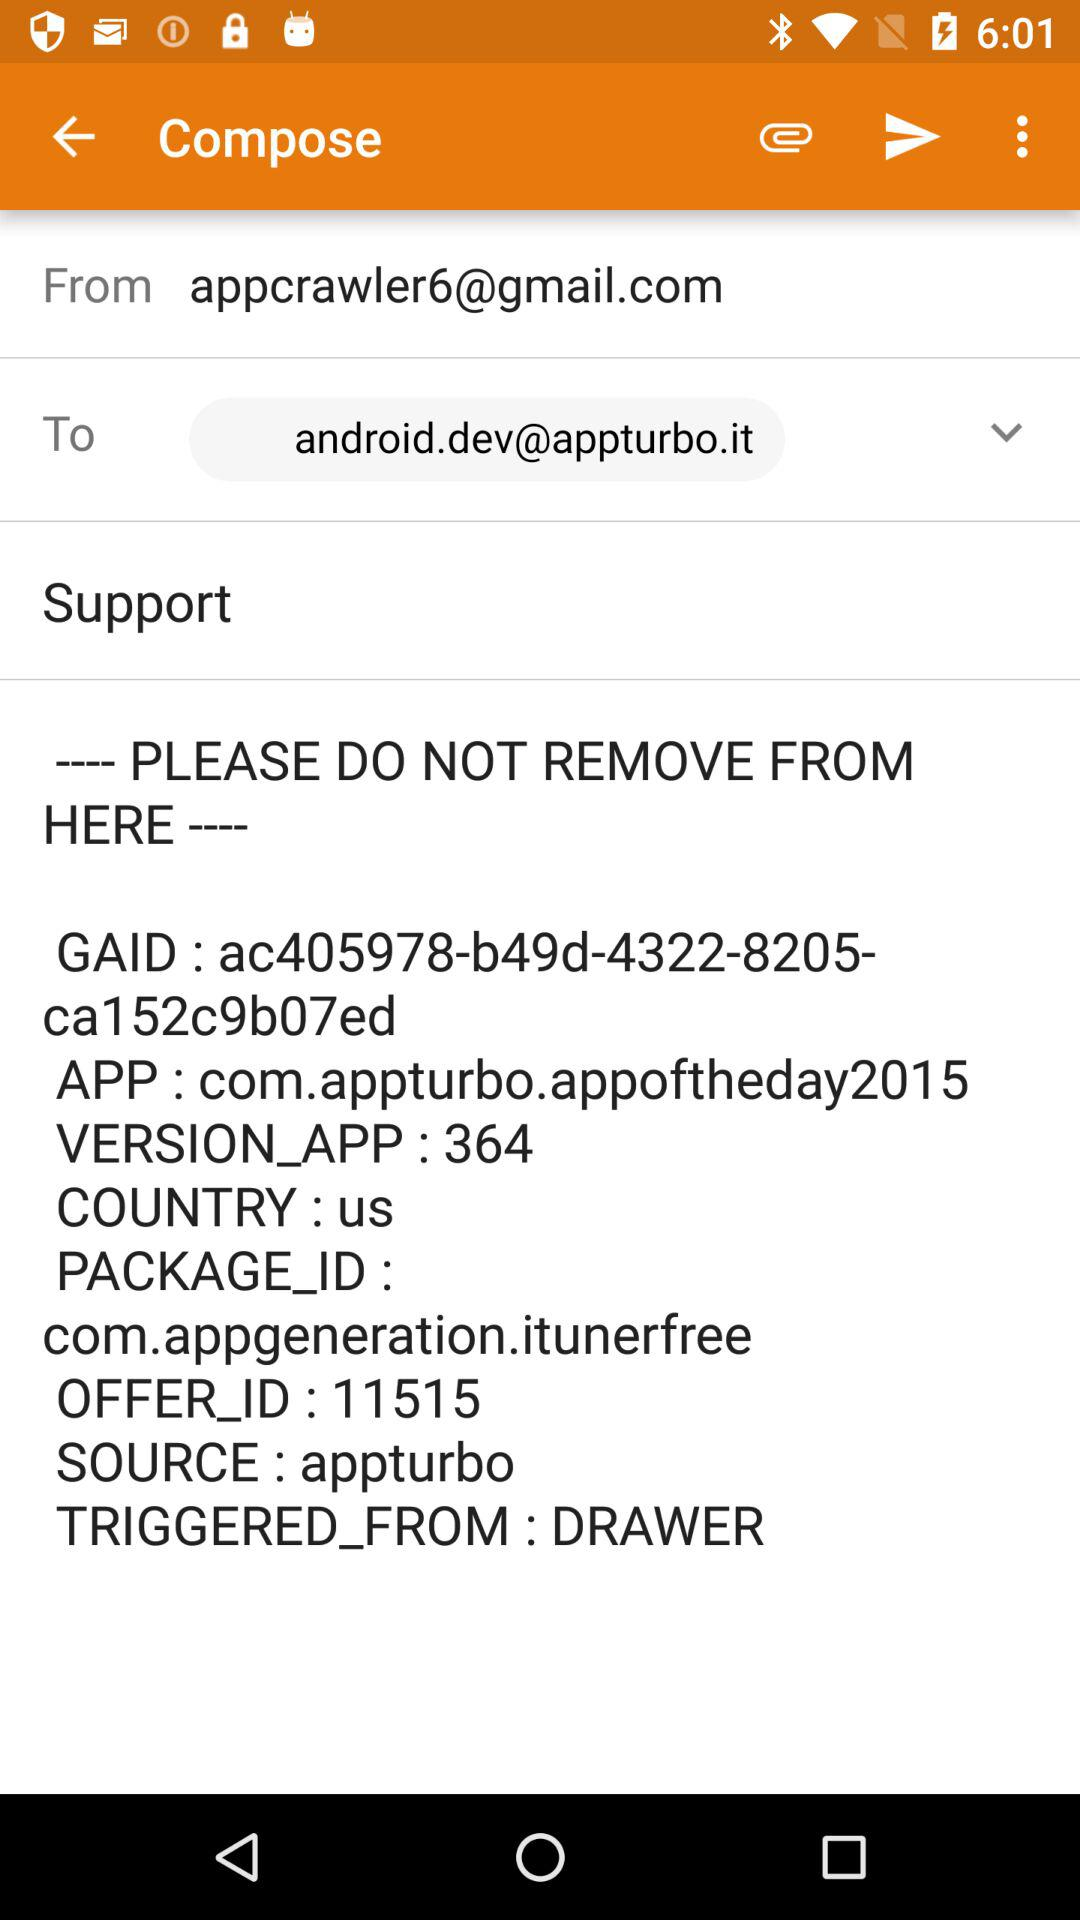Which country is mentioned? The mentioned country is the United States. 